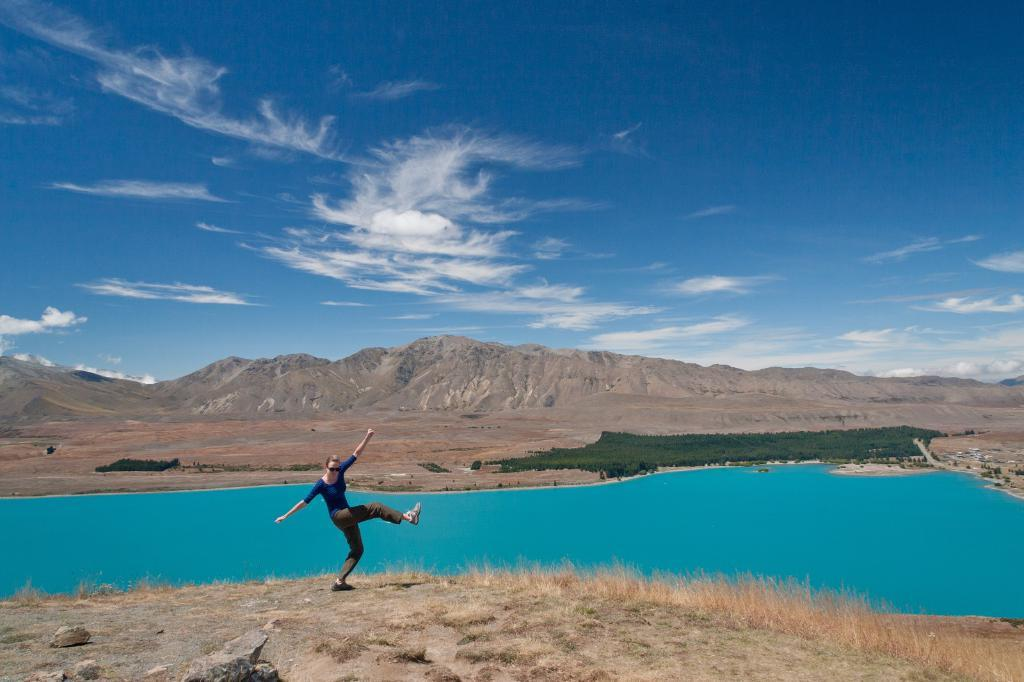Who is the main subject in the image? There is a girl in the image. What is the girl doing in the image? The girl is striking a pose in the image. What can be seen in the foreground of the image? There is water visible in the image. What is visible in the background of the image? There are mountains in the background of the image. What type of bird can be seen in the girl's office in the image? There is no bird or office present in the image; it features a girl striking a pose near water with mountains in the background. 